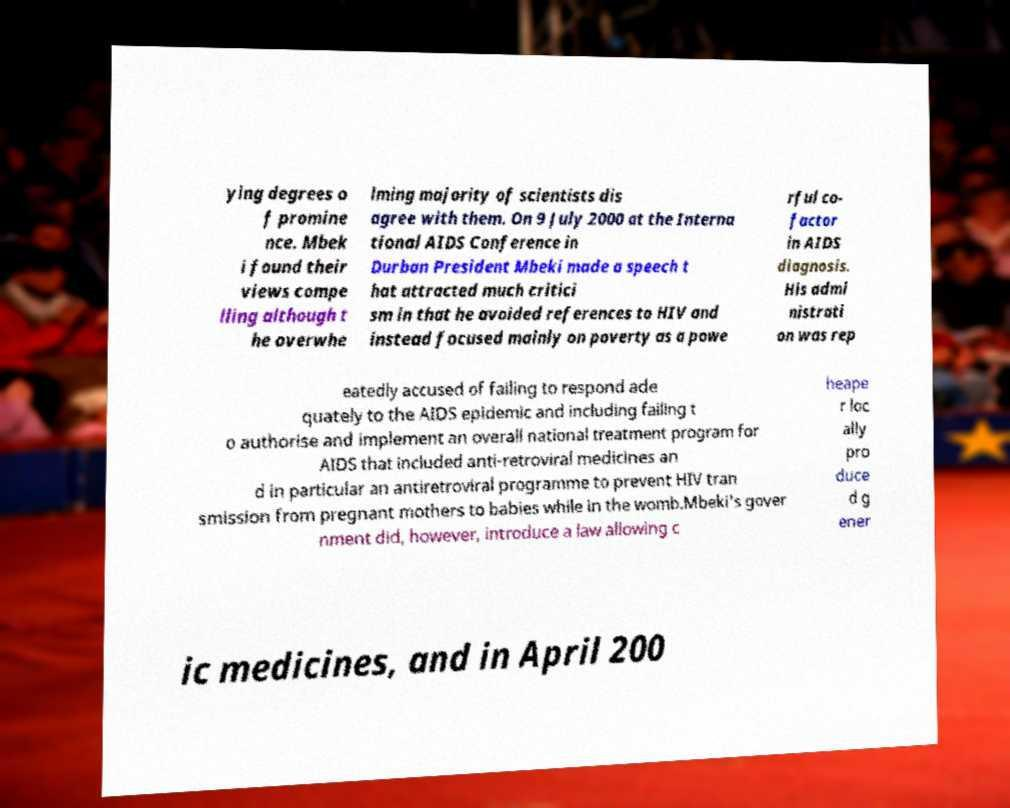There's text embedded in this image that I need extracted. Can you transcribe it verbatim? ying degrees o f promine nce. Mbek i found their views compe lling although t he overwhe lming majority of scientists dis agree with them. On 9 July 2000 at the Interna tional AIDS Conference in Durban President Mbeki made a speech t hat attracted much critici sm in that he avoided references to HIV and instead focused mainly on poverty as a powe rful co- factor in AIDS diagnosis. His admi nistrati on was rep eatedly accused of failing to respond ade quately to the AIDS epidemic and including failing t o authorise and implement an overall national treatment program for AIDS that included anti-retroviral medicines an d in particular an antiretroviral programme to prevent HIV tran smission from pregnant mothers to babies while in the womb.Mbeki's gover nment did, however, introduce a law allowing c heape r loc ally pro duce d g ener ic medicines, and in April 200 